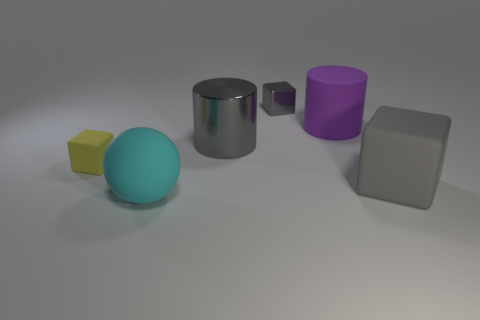Can you tell me what objects are present in this image and their colors? In this image, there are five objects. From left to right: a small yellow cube, a large cyan ball, a silver metal cylinder, a smaller purple cube, and a grey square block. 